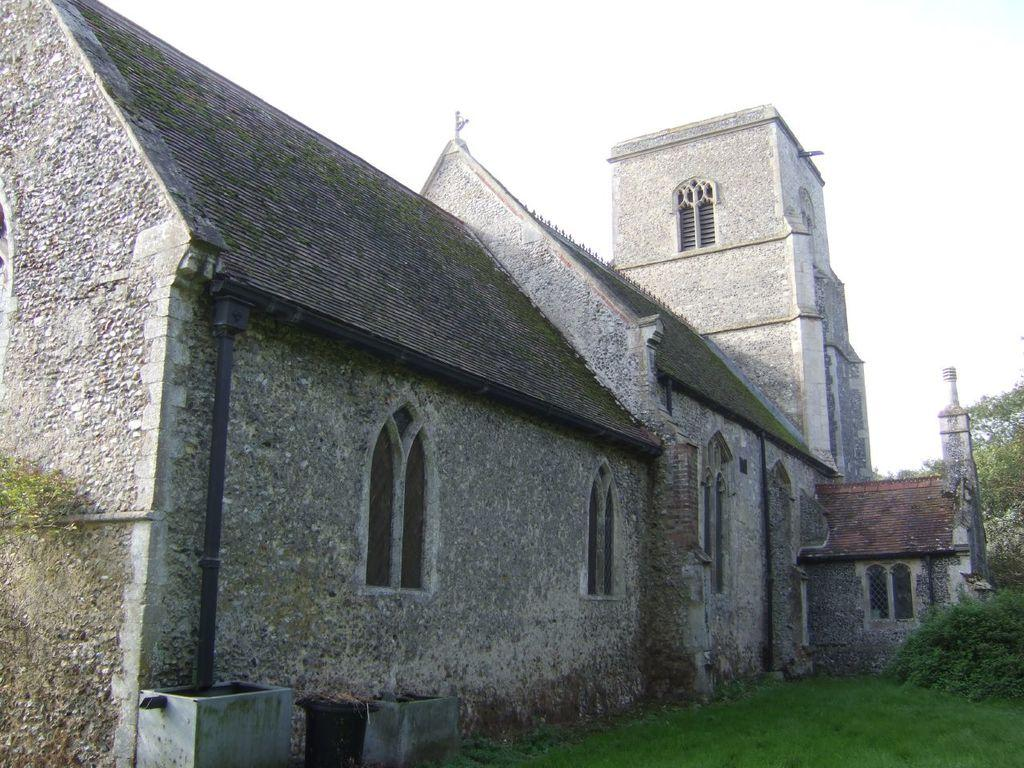What is the main structure in the center of the image? There is a house in the center of the image. What can be seen at the top of the image? The sky is visible at the top of the image. What type of vegetation is present at the bottom of the image? Grass is present at the bottom of the image. What is located on the right side of the image? There is a tree on the right side of the image. How does the star affect the lighting in the image? There is no star present in the image, so it cannot affect the lighting. 